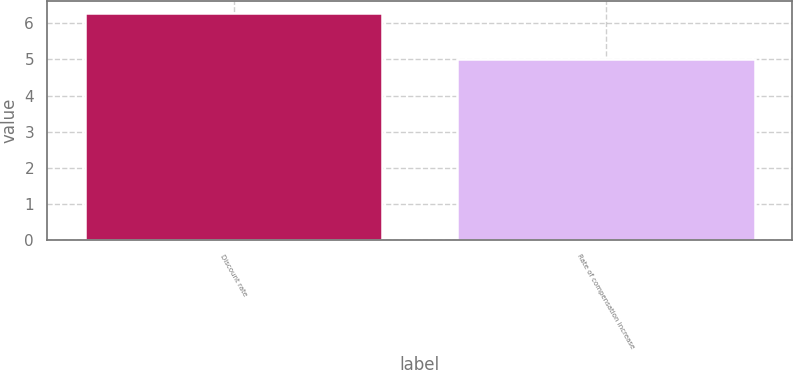<chart> <loc_0><loc_0><loc_500><loc_500><bar_chart><fcel>Discount rate<fcel>Rate of compensation increase<nl><fcel>6.3<fcel>5<nl></chart> 